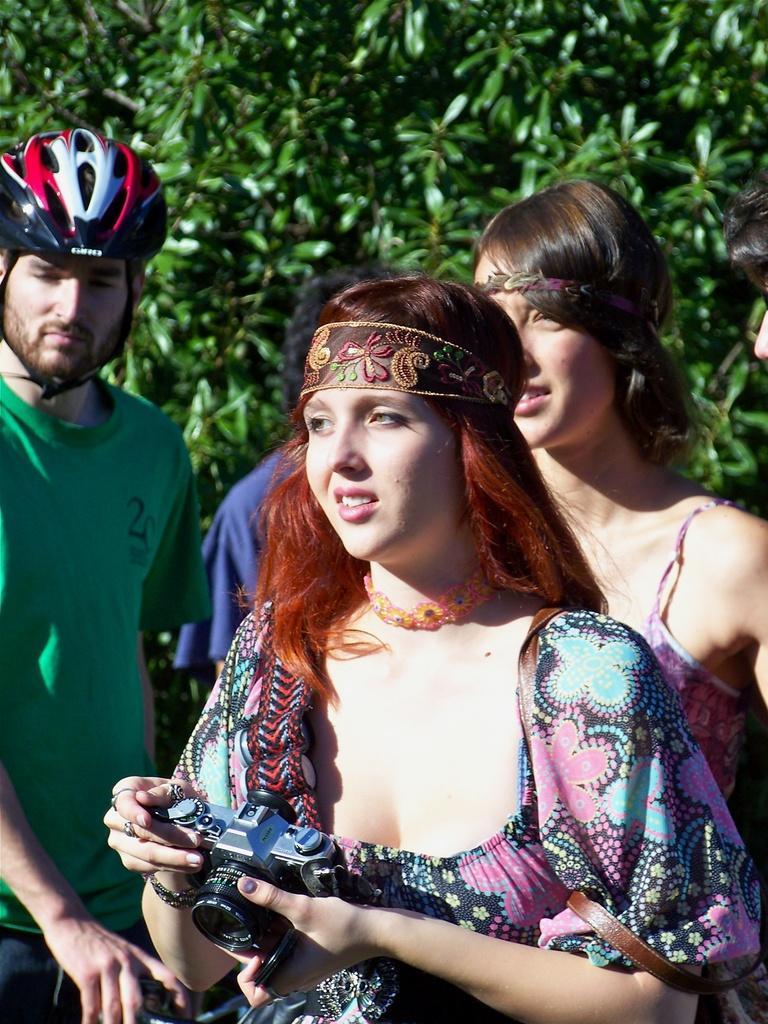Please provide a concise description of this image. We can see people are standing, this woman holding camera and this man wore helmet. Background we can see leaves. 